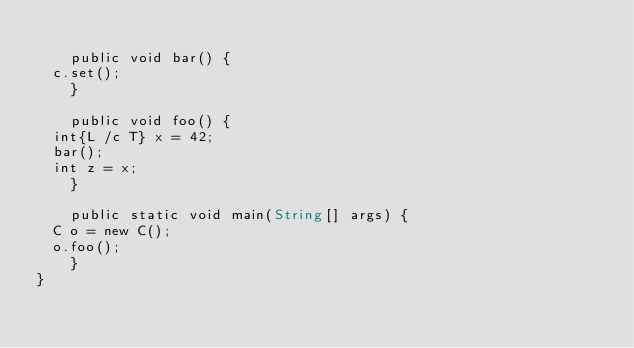<code> <loc_0><loc_0><loc_500><loc_500><_Julia_>    
    public void bar() {
	c.set();
    }

    public void foo() {
	int{L /c T} x = 42;
	bar();
	int z = x;
    }
    
    public static void main(String[] args) {
	C o = new C();
	o.foo();
    }
}
</code> 